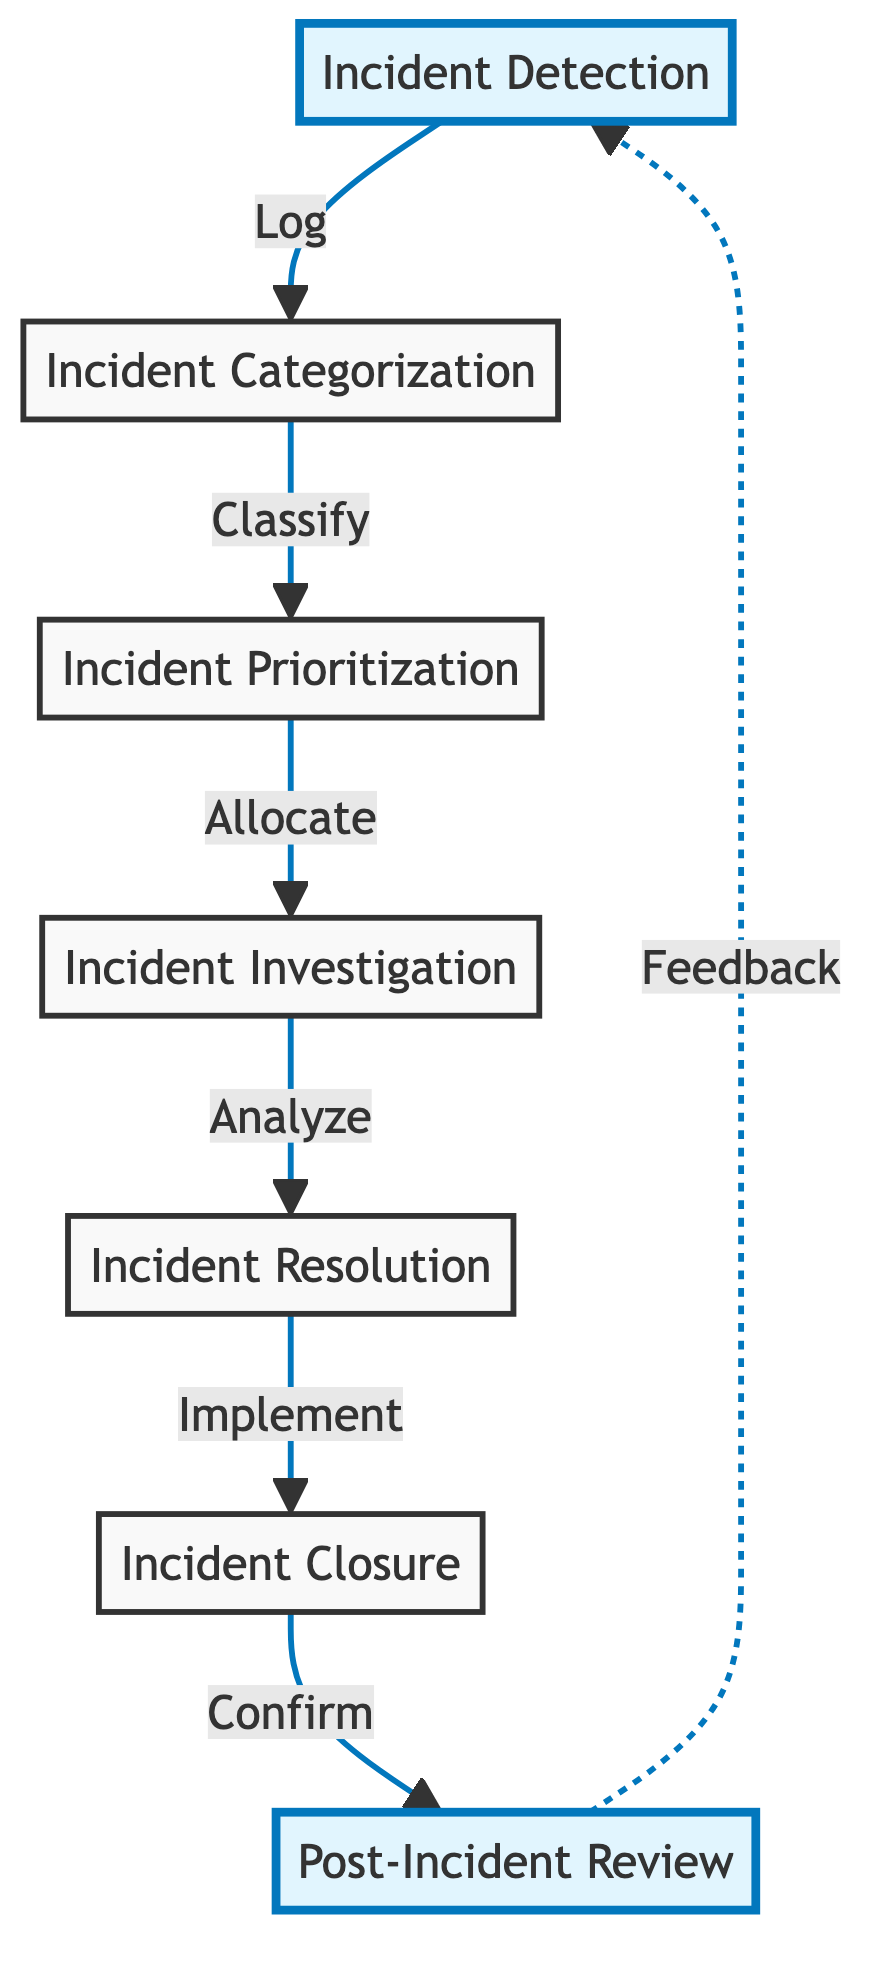What is the first step in the incident management process? The first step in the diagram is "Incident Detection," which indicates that this is where the process begins as incidents are identified and logged.
Answer: Incident Detection How many nodes are there in total? By counting each labeled box in the flow chart, there are seven distinct nodes representing various steps in the incident management process.
Answer: Seven What follows after Incident Categorization? According to the flow of the diagram, after "Incident Categorization," the next step is "Incident Prioritization," indicating that categorization leads directly to prioritization.
Answer: Incident Prioritization What is the final step depicted in the flowchart? The last node in the flow chart is "Post-Incident Review," indicating that this is the concluding step of the incident management process where evaluations take place.
Answer: Post-Incident Review How does the process return to the start? The flowchart shows that after "Post-Incident Review," there is a dotted line leading back to "Incident Detection," indicating that feedback from the review informs future incident detection.
Answer: Feedback What action is taken after Incident Resolution? Following "Incident Resolution," the next action taken is "Incident Closure," indicating that once a solution is implemented, formal closure of the incident occurs.
Answer: Incident Closure What key analysis is performed before resolution? The process indicates that "Incident Investigation" takes place before "Incident Resolution," highlighting that analysis of the incident is crucial to determine a fix.
Answer: Incident Investigation How many relationships are between the nodes? By analyzing the connections in the diagram, there are six directed relationships between the seven steps of the incident management process, indicating the flow of actions.
Answer: Six 